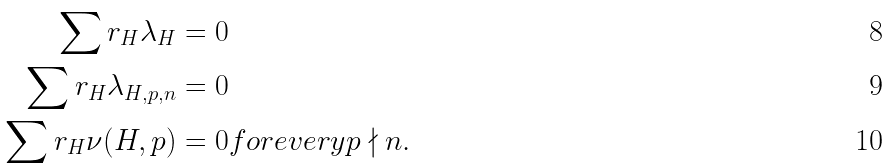<formula> <loc_0><loc_0><loc_500><loc_500>\sum r _ { H } \lambda _ { H } & = 0 \\ \sum r _ { H } \lambda _ { H , p , n } & = 0 \\ \sum r _ { H } \nu ( H , p ) & = 0 f o r e v e r y p \nmid n .</formula> 